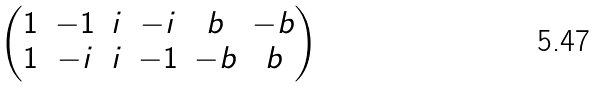Convert formula to latex. <formula><loc_0><loc_0><loc_500><loc_500>\begin{pmatrix} 1 & - 1 & i & - i & b & - b \\ 1 & - i & i & - 1 & - b & b \end{pmatrix}</formula> 